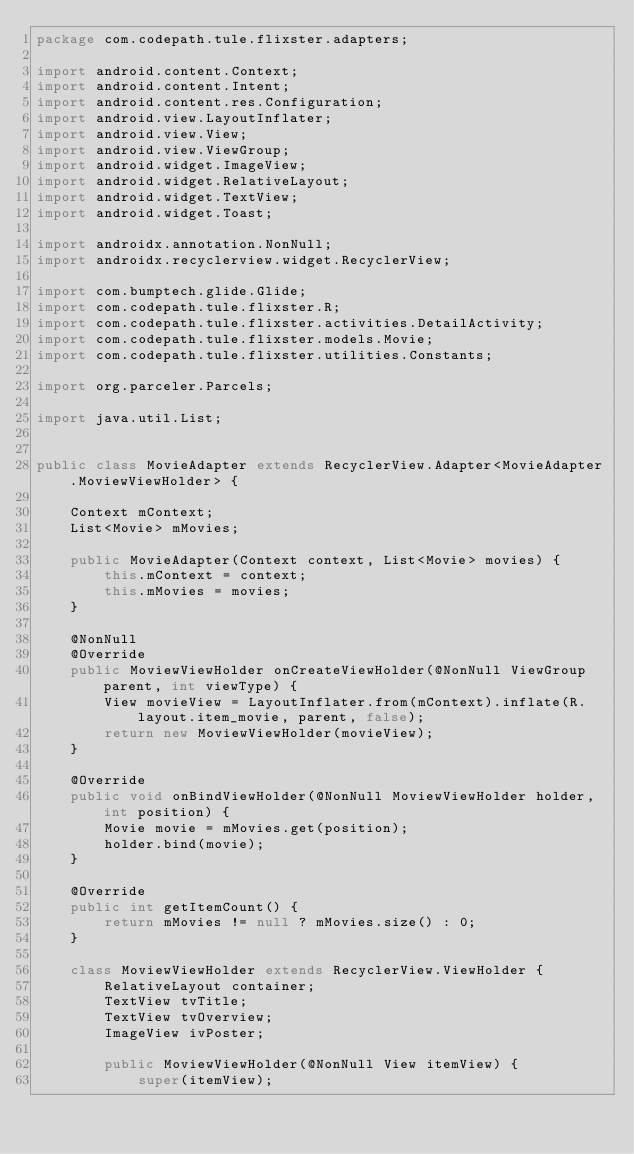Convert code to text. <code><loc_0><loc_0><loc_500><loc_500><_Java_>package com.codepath.tule.flixster.adapters;

import android.content.Context;
import android.content.Intent;
import android.content.res.Configuration;
import android.view.LayoutInflater;
import android.view.View;
import android.view.ViewGroup;
import android.widget.ImageView;
import android.widget.RelativeLayout;
import android.widget.TextView;
import android.widget.Toast;

import androidx.annotation.NonNull;
import androidx.recyclerview.widget.RecyclerView;

import com.bumptech.glide.Glide;
import com.codepath.tule.flixster.R;
import com.codepath.tule.flixster.activities.DetailActivity;
import com.codepath.tule.flixster.models.Movie;
import com.codepath.tule.flixster.utilities.Constants;

import org.parceler.Parcels;

import java.util.List;


public class MovieAdapter extends RecyclerView.Adapter<MovieAdapter.MoviewViewHolder> {

    Context mContext;
    List<Movie> mMovies;

    public MovieAdapter(Context context, List<Movie> movies) {
        this.mContext = context;
        this.mMovies = movies;
    }

    @NonNull
    @Override
    public MoviewViewHolder onCreateViewHolder(@NonNull ViewGroup parent, int viewType) {
        View movieView = LayoutInflater.from(mContext).inflate(R.layout.item_movie, parent, false);
        return new MoviewViewHolder(movieView);
    }

    @Override
    public void onBindViewHolder(@NonNull MoviewViewHolder holder, int position) {
        Movie movie = mMovies.get(position);
        holder.bind(movie);
    }

    @Override
    public int getItemCount() {
        return mMovies != null ? mMovies.size() : 0;
    }

    class MoviewViewHolder extends RecyclerView.ViewHolder {
        RelativeLayout container;
        TextView tvTitle;
        TextView tvOverview;
        ImageView ivPoster;

        public MoviewViewHolder(@NonNull View itemView) {
            super(itemView);</code> 